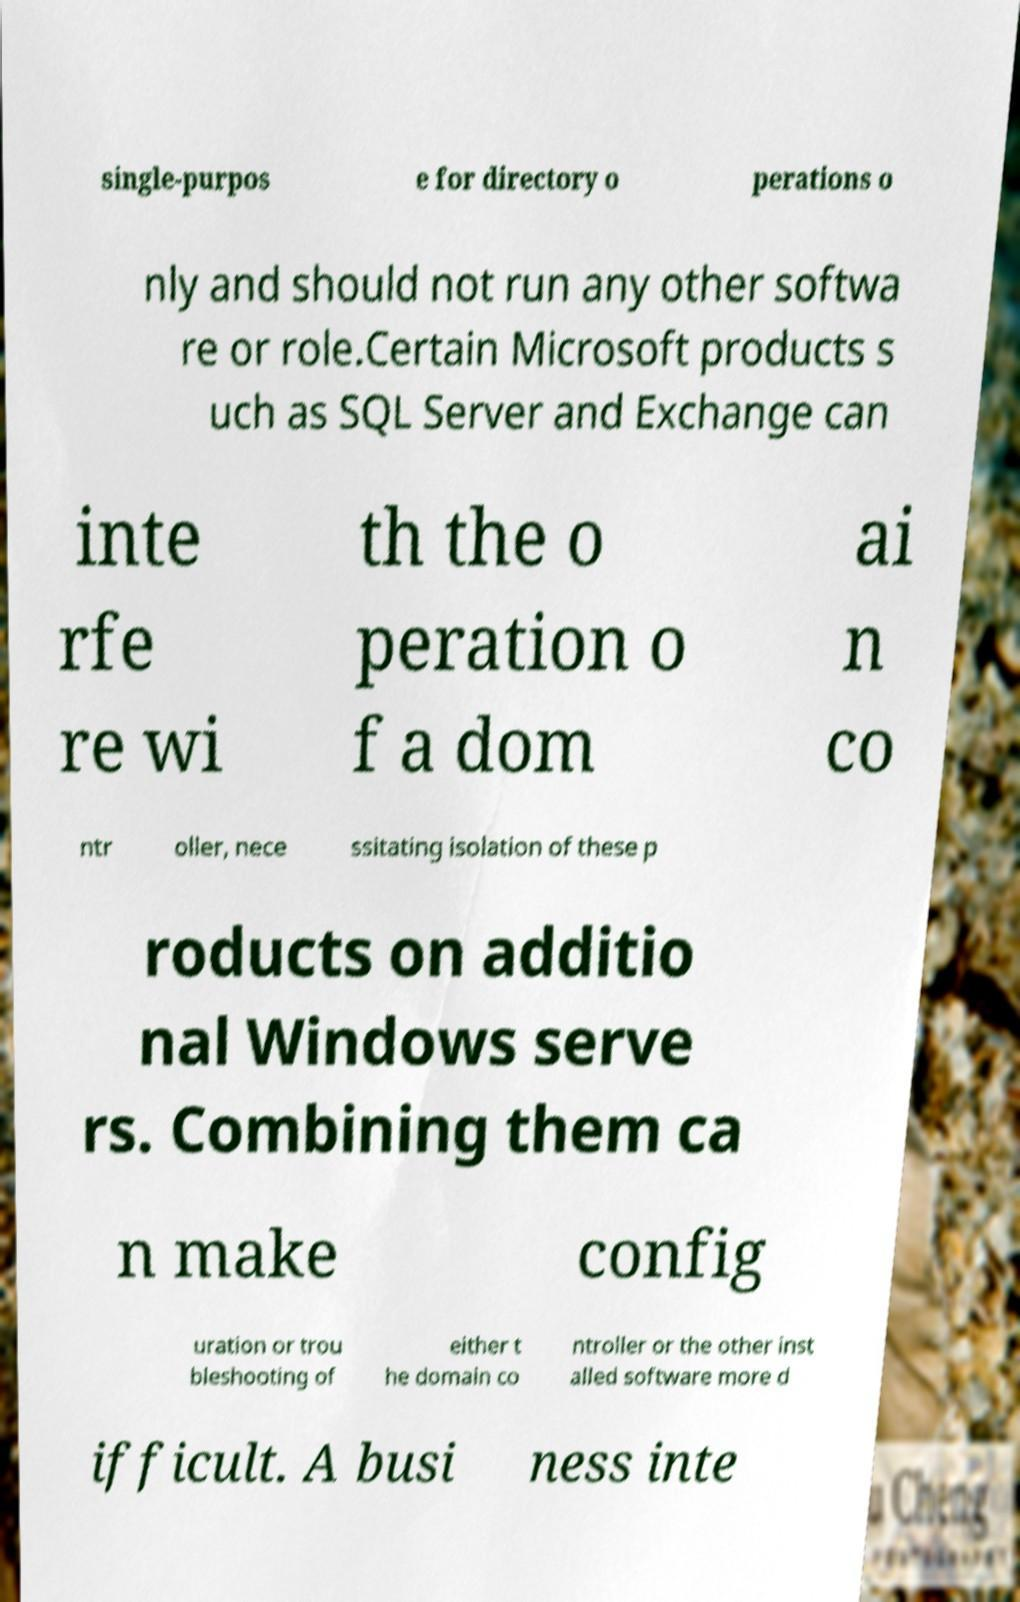Could you extract and type out the text from this image? single-purpos e for directory o perations o nly and should not run any other softwa re or role.Certain Microsoft products s uch as SQL Server and Exchange can inte rfe re wi th the o peration o f a dom ai n co ntr oller, nece ssitating isolation of these p roducts on additio nal Windows serve rs. Combining them ca n make config uration or trou bleshooting of either t he domain co ntroller or the other inst alled software more d ifficult. A busi ness inte 